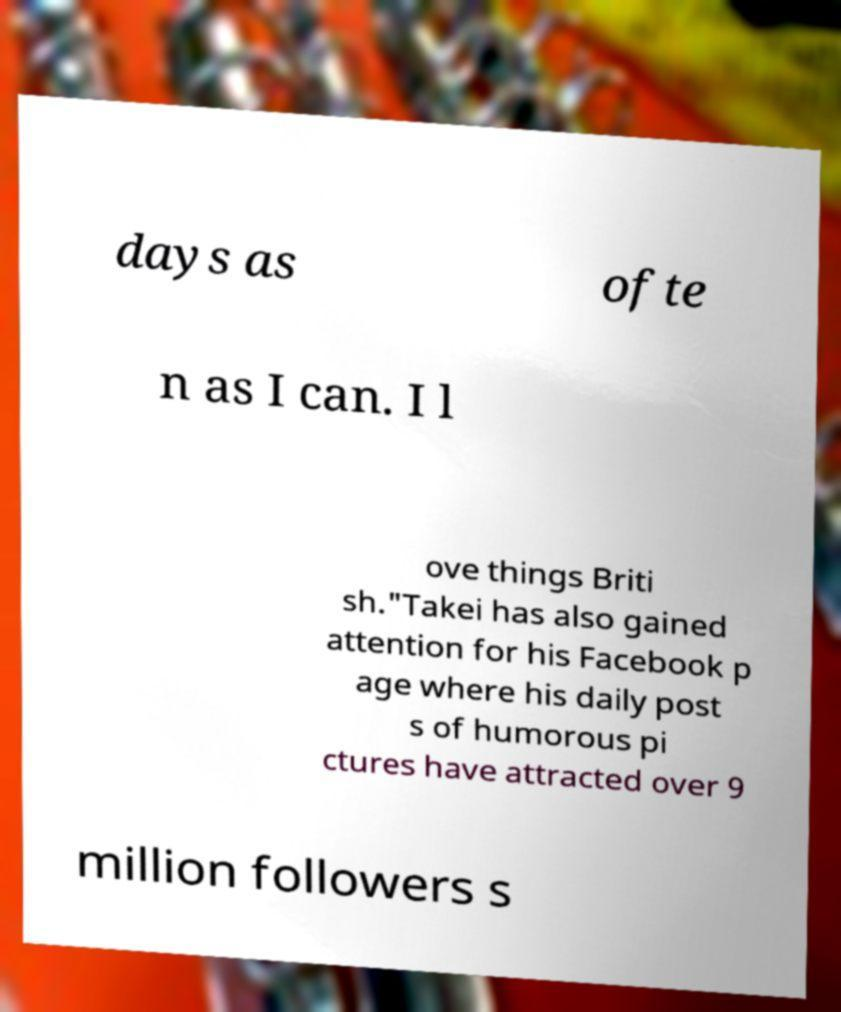What messages or text are displayed in this image? I need them in a readable, typed format. days as ofte n as I can. I l ove things Briti sh."Takei has also gained attention for his Facebook p age where his daily post s of humorous pi ctures have attracted over 9 million followers s 